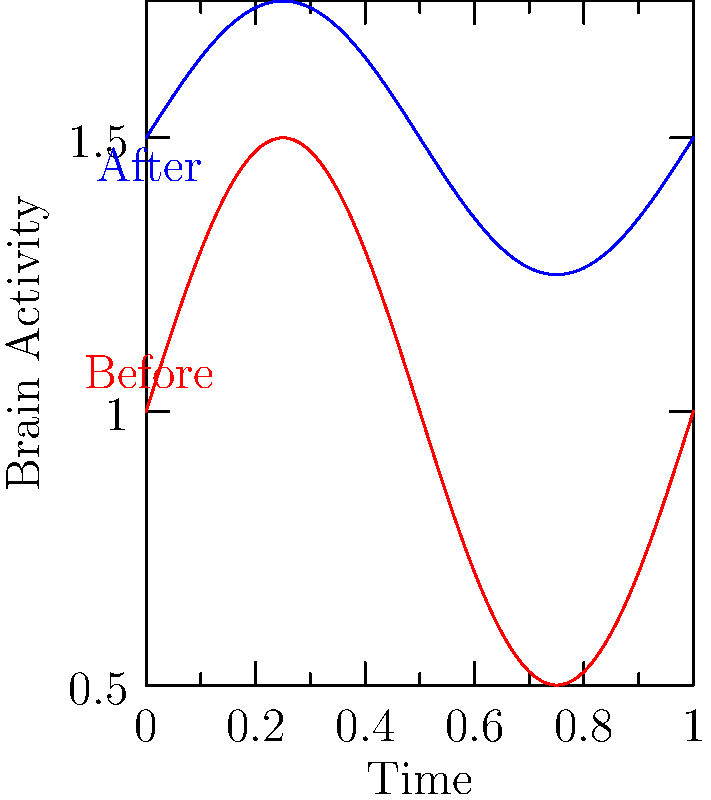Analyzing the brain scans before and after therapy, what change can be observed in the patient's brain activity pattern? To answer this question, we need to carefully examine the two curves representing brain activity before and after therapy:

1. Amplitude: The red curve (before therapy) has a larger amplitude compared to the blue curve (after therapy). This indicates that the fluctuations in brain activity were more extreme before therapy.

2. Baseline activity: The blue curve (after therapy) is generally higher on the y-axis, suggesting an overall increase in baseline brain activity.

3. Regularity: Both curves follow a sinusoidal pattern, but the after-therapy curve (blue) appears more regular and less erratic.

4. Frequency: The frequency of the oscillations remains the same for both curves, indicating that the therapy did not change the overall rhythm of brain activity.

Considering these observations, we can conclude that the main change in the patient's brain activity pattern is a reduction in the amplitude of fluctuations coupled with an increase in baseline activity. This suggests a more stable and consistently active brain state after therapy.
Answer: Reduced amplitude of fluctuations and increased baseline activity 